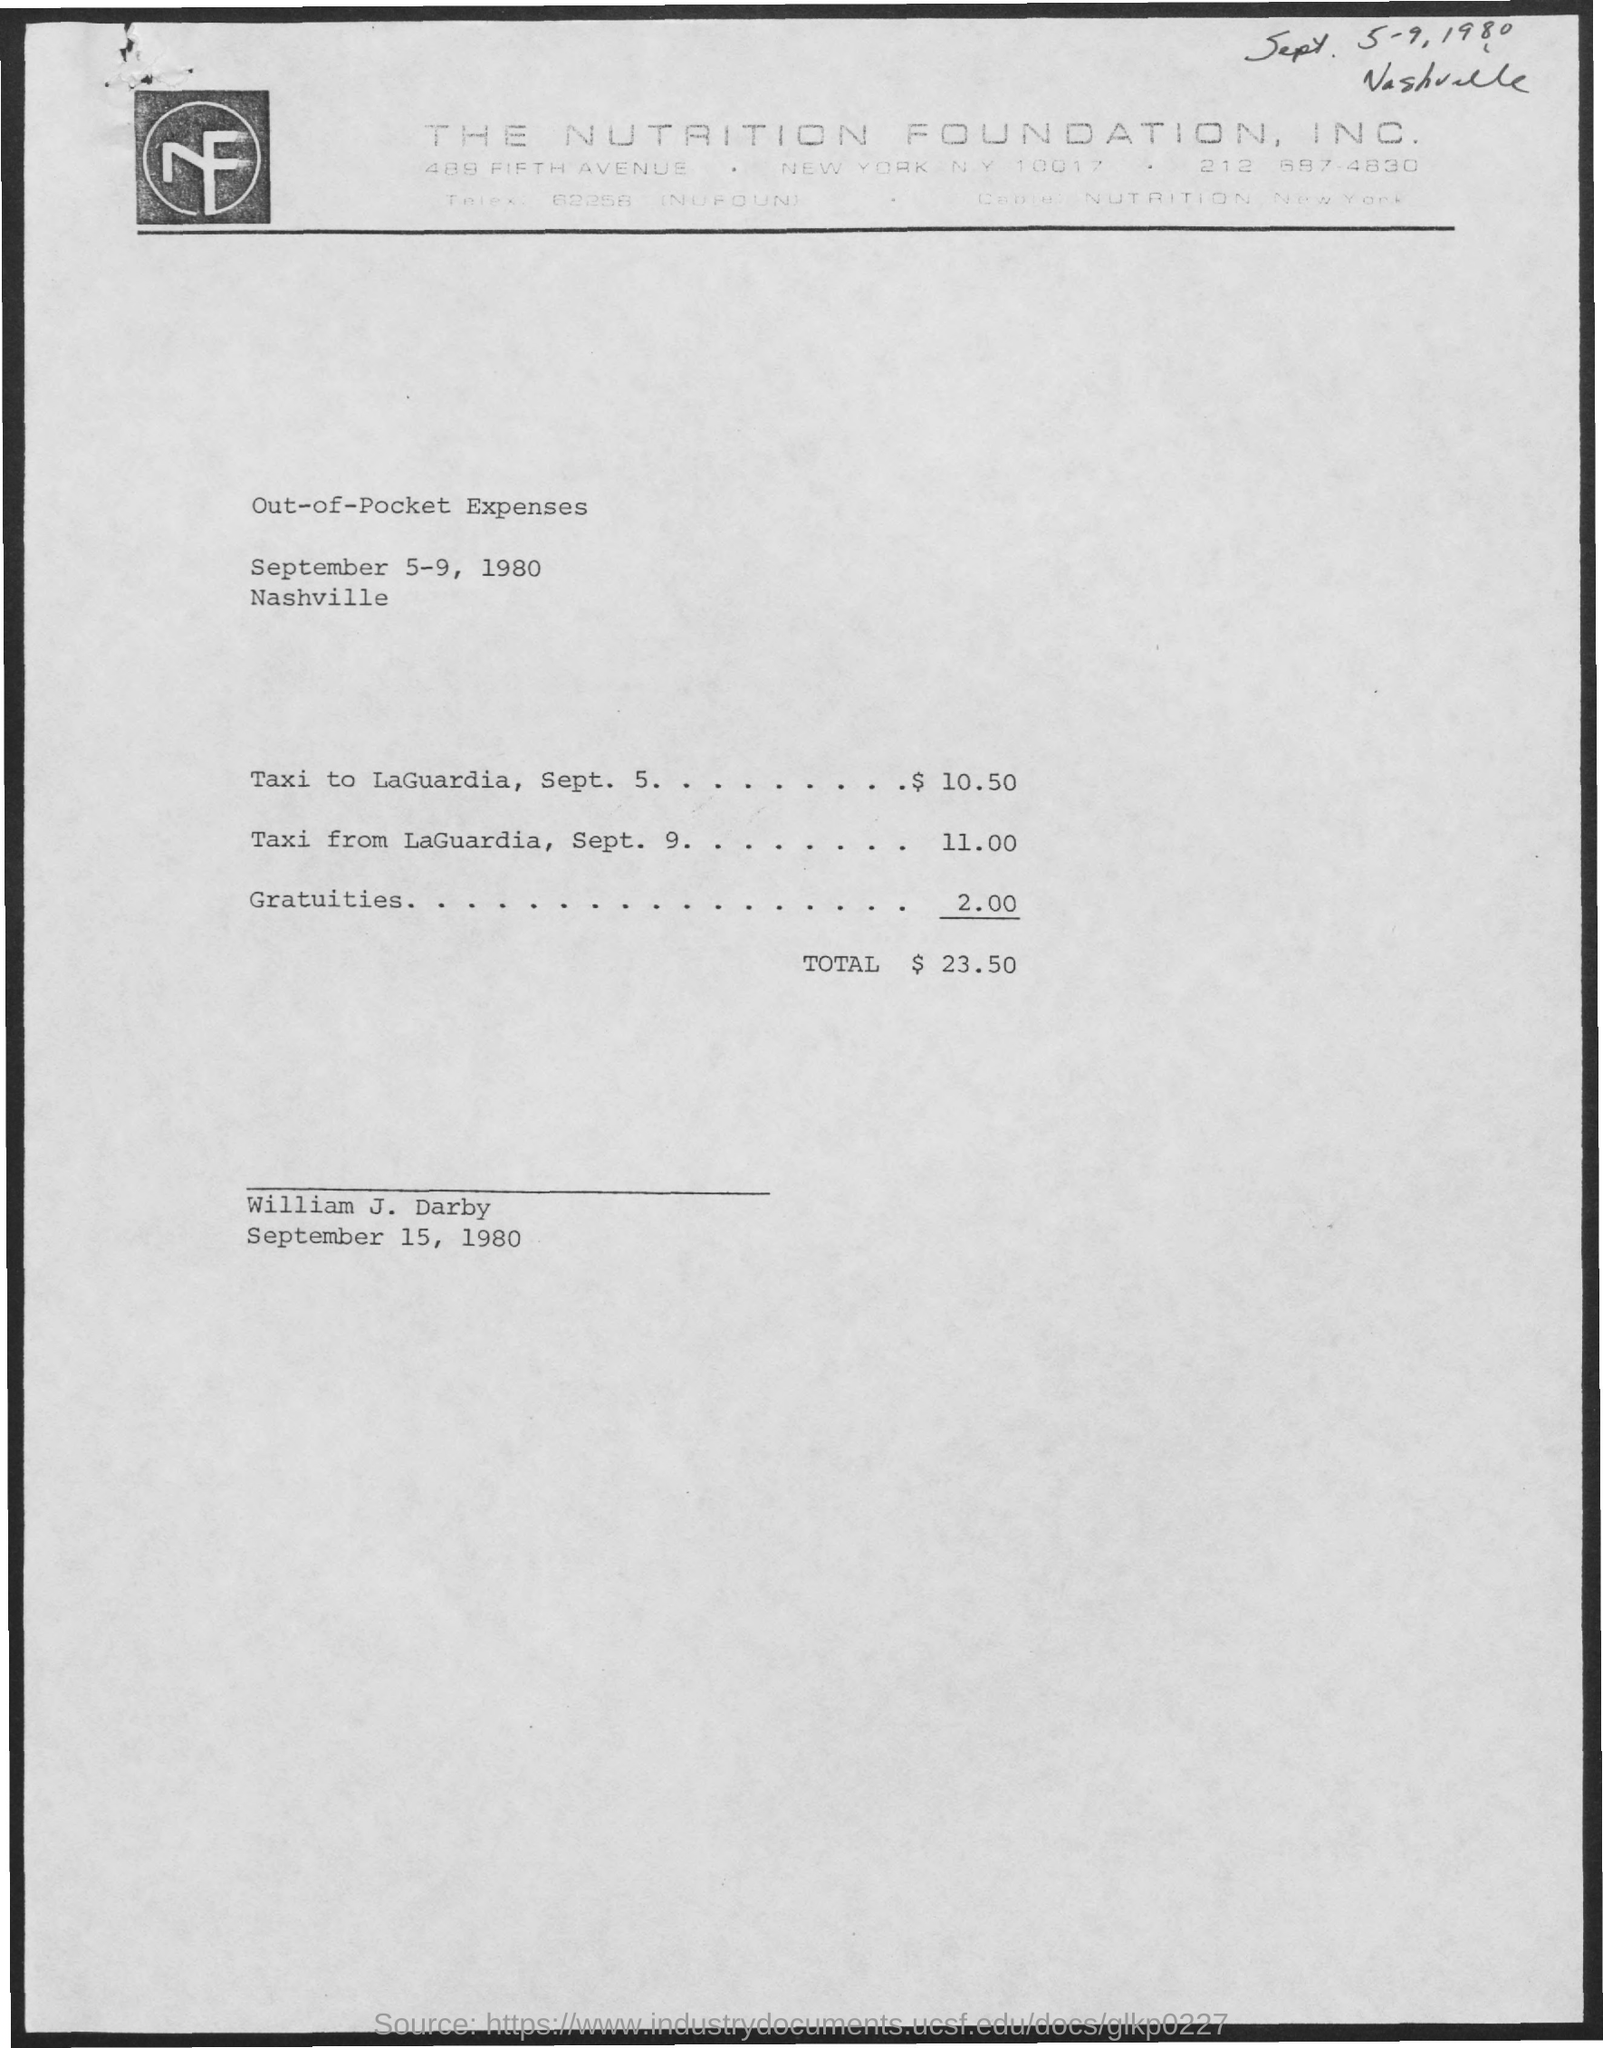Identify some key points in this picture. The expenses for a taxi ride from La Guardia on September 9th were $11.00. On September 5th, the expenses for a taxi to LaGuardia were $10.50. The meeting is scheduled to take place from September 5-9, 1980, as indicated in the given page. The expenses for guests as mentioned in the given form are $2.00. The total expenses mentioned on the given page are $23.50. 